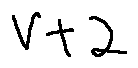<formula> <loc_0><loc_0><loc_500><loc_500>V + 2</formula> 